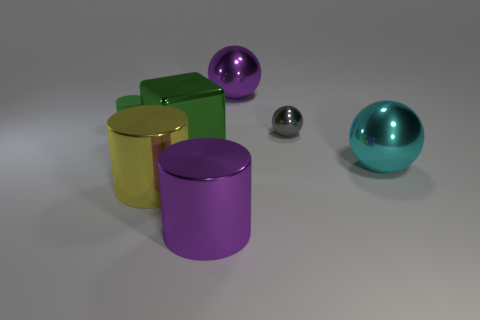Add 2 cyan shiny things. How many objects exist? 9 Subtract all spheres. How many objects are left? 4 Subtract all purple cylinders. Subtract all small gray things. How many objects are left? 5 Add 4 green cylinders. How many green cylinders are left? 5 Add 4 big blue metallic objects. How many big blue metallic objects exist? 4 Subtract 0 gray cylinders. How many objects are left? 7 